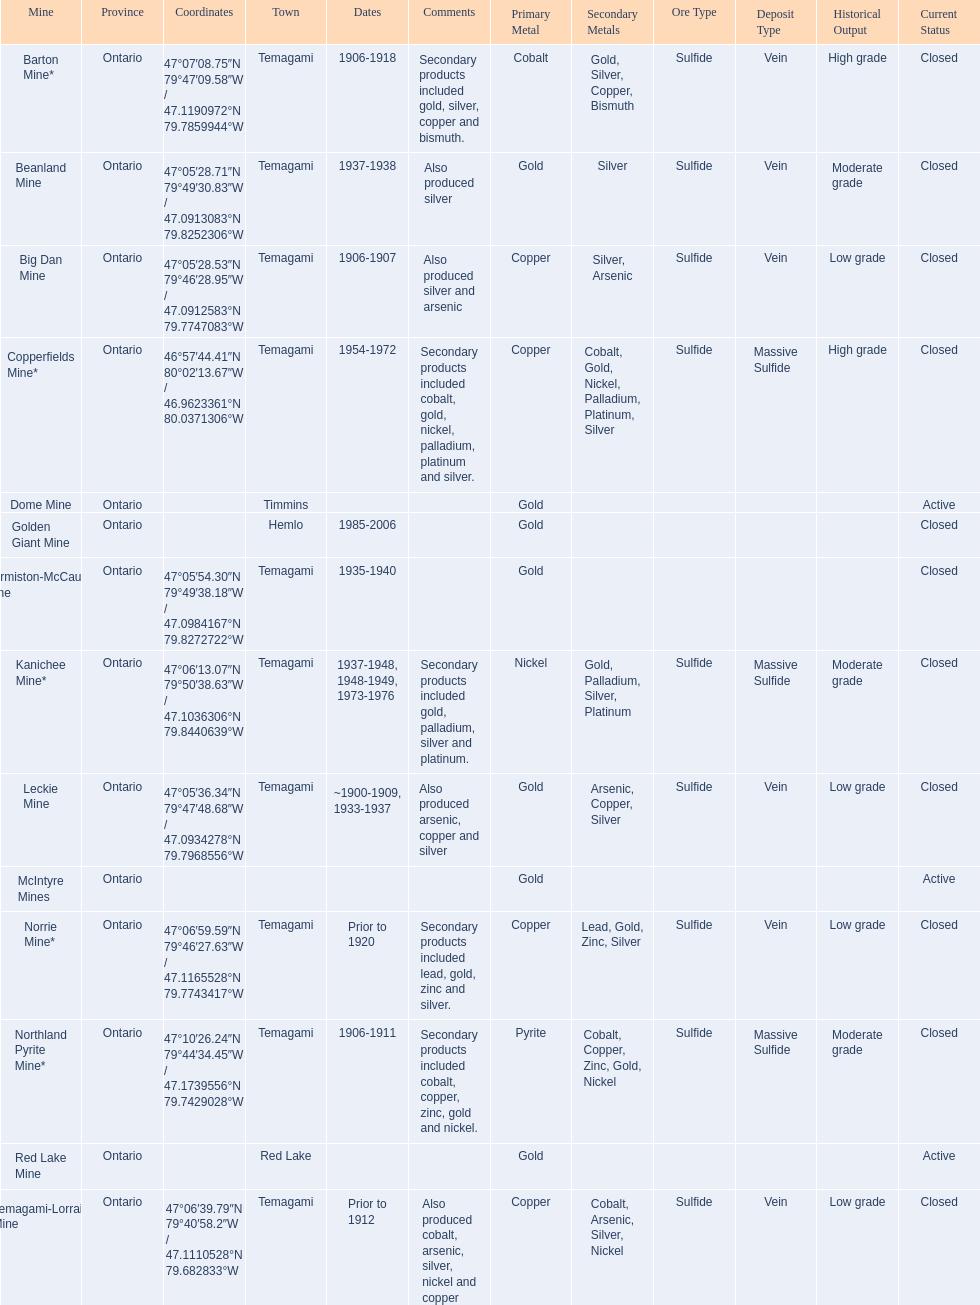What are all the mines with dates listed? Barton Mine*, Beanland Mine, Big Dan Mine, Copperfields Mine*, Golden Giant Mine, Hermiston-McCauley Mine, Kanichee Mine*, Leckie Mine, Norrie Mine*, Northland Pyrite Mine*, Temagami-Lorrain Mine. Which of those dates include the year that the mine was closed? 1906-1918, 1937-1938, 1906-1907, 1954-1972, 1985-2006, 1935-1940, 1937-1948, 1948-1949, 1973-1976, ~1900-1909, 1933-1937, 1906-1911. Which of those mines were opened the longest? Golden Giant Mine. 